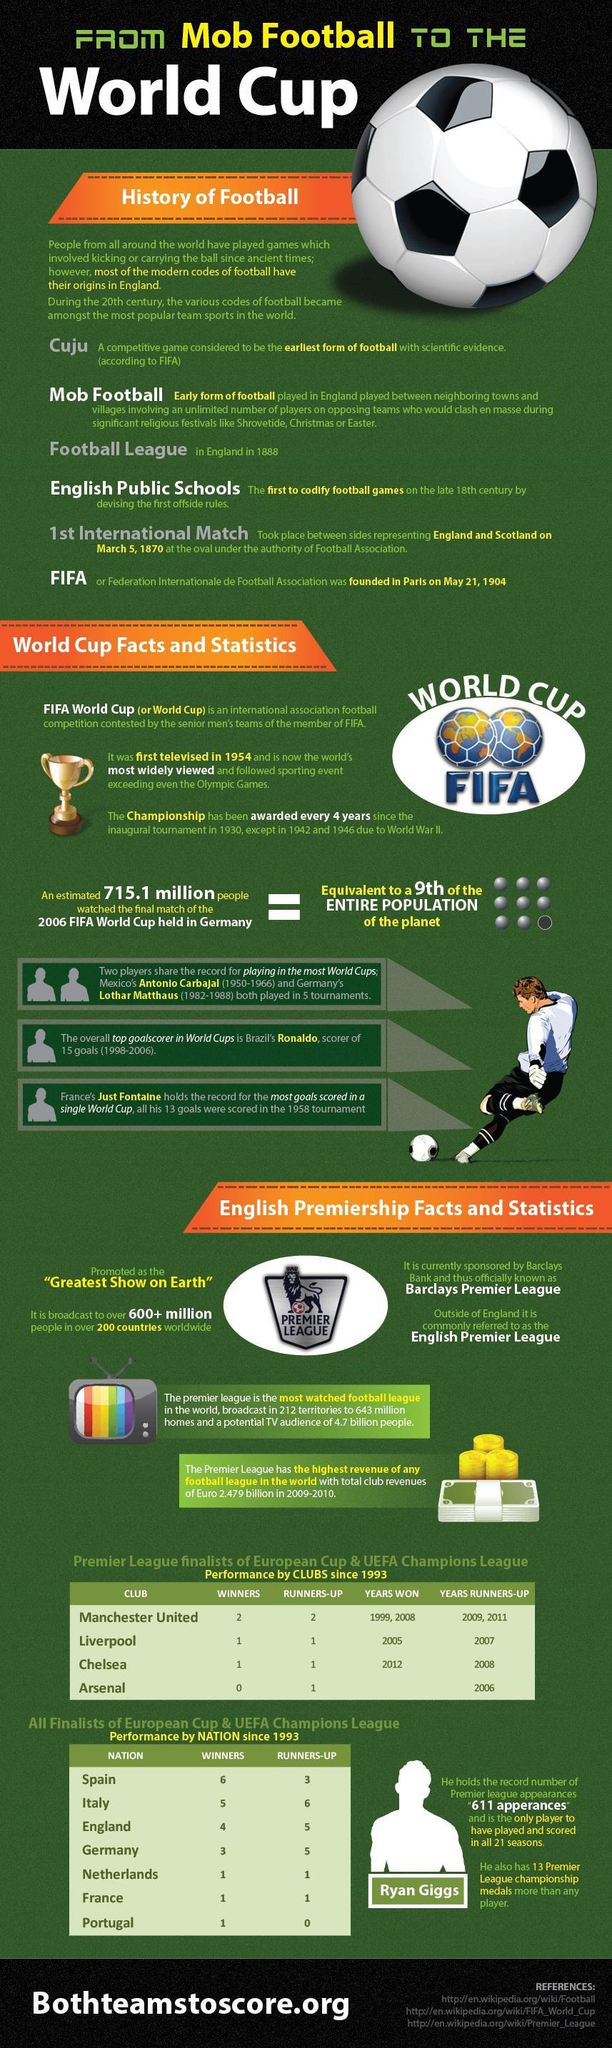Which event was expected to be watched by the equivalent of 1/9th of earth's population?
Answer the question with a short phrase. final match of 2006 FIFA World Cup Which player from Mexico has played in 5 world cup tournaments? Antonio Carbajal Who is the current sponsor of the English Premier League? Barclays Bank Who holds the record of 611 premier league appearances? Ryan Giggs What is broadcast to over 600+ million people in 200 countries worldwide? English Premier League In which years was the FIFA World Cup not held as per schedule? 1942, 1946 How many people were expected to watch the 2006 FIFA world cup final match? 715.1 million What is the English Premiership officially known as? Barclays Premier League Which German player shares the record for playing in the most World Cups? Lothar Matthaus 